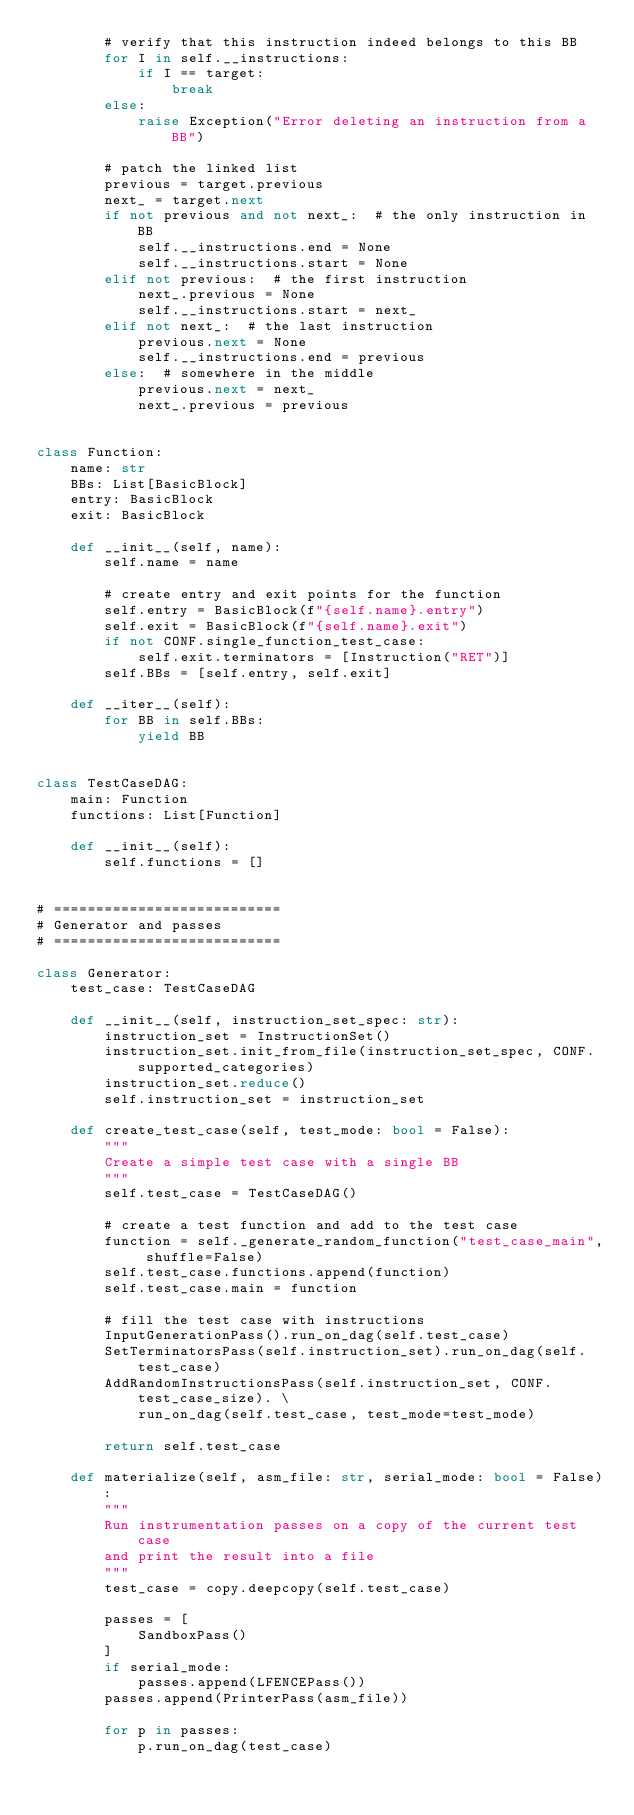Convert code to text. <code><loc_0><loc_0><loc_500><loc_500><_Python_>        # verify that this instruction indeed belongs to this BB
        for I in self.__instructions:
            if I == target:
                break
        else:
            raise Exception("Error deleting an instruction from a BB")

        # patch the linked list
        previous = target.previous
        next_ = target.next
        if not previous and not next_:  # the only instruction in BB
            self.__instructions.end = None
            self.__instructions.start = None
        elif not previous:  # the first instruction
            next_.previous = None
            self.__instructions.start = next_
        elif not next_:  # the last instruction
            previous.next = None
            self.__instructions.end = previous
        else:  # somewhere in the middle
            previous.next = next_
            next_.previous = previous


class Function:
    name: str
    BBs: List[BasicBlock]
    entry: BasicBlock
    exit: BasicBlock

    def __init__(self, name):
        self.name = name

        # create entry and exit points for the function
        self.entry = BasicBlock(f"{self.name}.entry")
        self.exit = BasicBlock(f"{self.name}.exit")
        if not CONF.single_function_test_case:
            self.exit.terminators = [Instruction("RET")]
        self.BBs = [self.entry, self.exit]

    def __iter__(self):
        for BB in self.BBs:
            yield BB


class TestCaseDAG:
    main: Function
    functions: List[Function]

    def __init__(self):
        self.functions = []


# ===========================
# Generator and passes
# ===========================

class Generator:
    test_case: TestCaseDAG

    def __init__(self, instruction_set_spec: str):
        instruction_set = InstructionSet()
        instruction_set.init_from_file(instruction_set_spec, CONF.supported_categories)
        instruction_set.reduce()
        self.instruction_set = instruction_set

    def create_test_case(self, test_mode: bool = False):
        """
        Create a simple test case with a single BB
        """
        self.test_case = TestCaseDAG()

        # create a test function and add to the test case
        function = self._generate_random_function("test_case_main", shuffle=False)
        self.test_case.functions.append(function)
        self.test_case.main = function

        # fill the test case with instructions
        InputGenerationPass().run_on_dag(self.test_case)
        SetTerminatorsPass(self.instruction_set).run_on_dag(self.test_case)
        AddRandomInstructionsPass(self.instruction_set, CONF.test_case_size). \
            run_on_dag(self.test_case, test_mode=test_mode)

        return self.test_case

    def materialize(self, asm_file: str, serial_mode: bool = False):
        """
        Run instrumentation passes on a copy of the current test case
        and print the result into a file
        """
        test_case = copy.deepcopy(self.test_case)

        passes = [
            SandboxPass()
        ]
        if serial_mode:
            passes.append(LFENCEPass())
        passes.append(PrinterPass(asm_file))

        for p in passes:
            p.run_on_dag(test_case)
</code> 